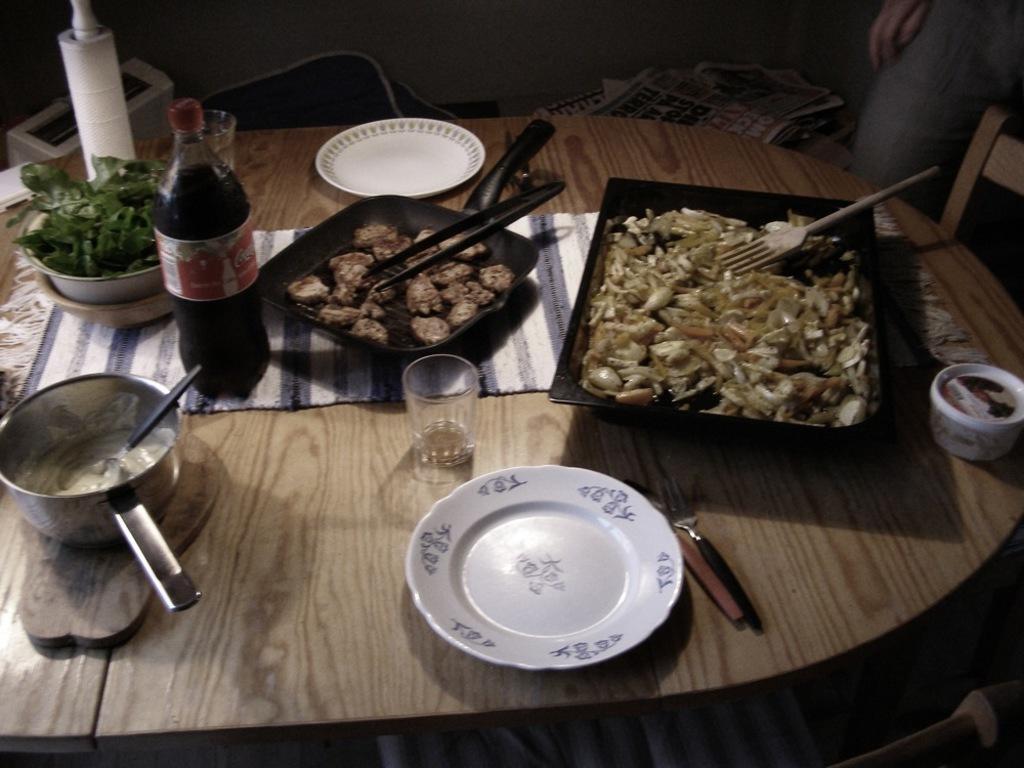Please provide a concise description of this image. In this picture we can see a table. On the table there are plates, bowl, bottle, and some food. 